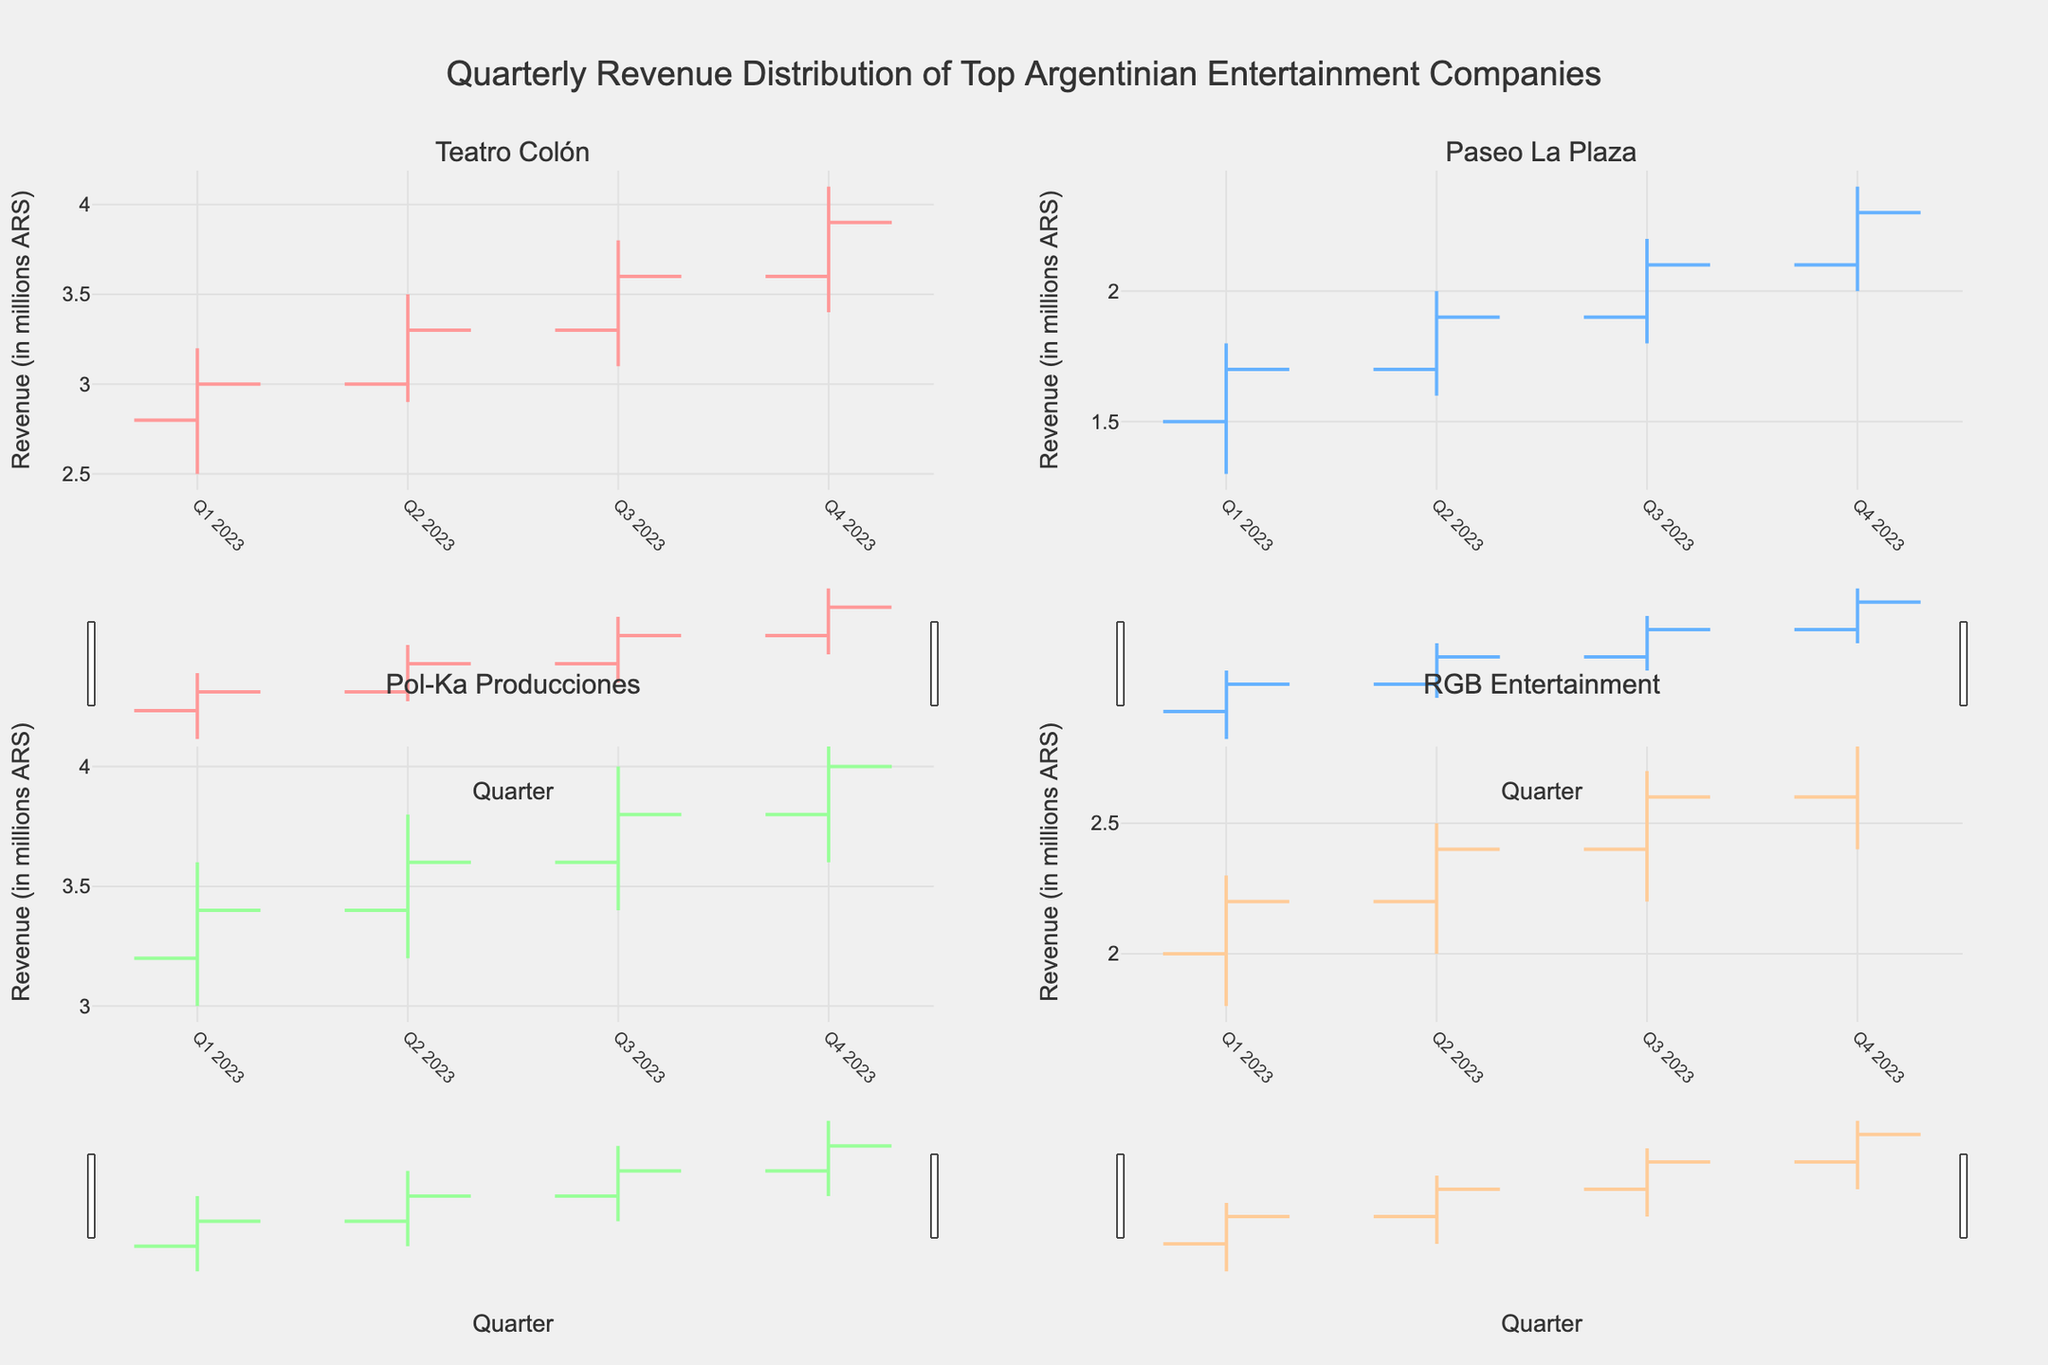What's the main title of the figure? The title is displayed prominently at the top of the figure, providing an overview of what's being shown. It can be read directly from the figure.
Answer: Quarterly Revenue Distribution of Top Argentinian Entertainment Companies Which company had the highest revenue in Q4 2023? To find the company with the highest revenue in Q4 2023, look at the High values in the Q4 2023 entries for all companies. Compare them to find the maximum value.
Answer: Pol-Ka Producciones What's the revenue range for Teatro Colón in Q2 2023? The revenue range is determined by the Low and High values. For Teatro Colón in Q2 2023, check the Low and High values in the second quarter.
Answer: 2.9 to 3.5 million ARS How did Paseo La Plaza's revenue change from Q1 2023 to Q4 2023? To determine the change, look at the Close values for Q1 2023 and Q4 2023 for Paseo La Plaza and subtract the Q1 value from the Q4 value.
Answer: Increase by 0.6 million ARS Which company showed the most consistent growth throughout 2023? Consistent growth means the Close values should incrementally increase each quarter. Compare the Close values for each quarter for all companies to see which one fits this pattern best.
Answer: Pol-Ka Producciones What's the average revenue of RGB Entertainment in 2023? Calculate the average by summing the Close values for all four quarters for RGB Entertainment and then divide by 4. Close values are 2.2, 2.4, 2.6, and 2.8. The sum is (2.2 + 2.4 + 2.6 + 2.8) = 10. The average is 10 / 4.
Answer: 2.5 million ARS Which quarter had the highest revenue for Teatro Colón? Check the High values for all quarters for Teatro Colón and determine which quarter has the highest High value.
Answer: Q4 2023 Was there any quarter when Paseo La Plaza's revenue decreased compared to the previous quarter? Compare the Close values of consecutive quarters for Paseo La Plaza and see if any quarter has a lower value than the previous one.
Answer: No What's the median closing revenue for Pol-Ka Producciones in 2023? To find the median, list the Close values for all quarters in ascending order and find the middle value. If there's an even number of values, average the two middle ones. The Close values are 3.4, 3.6, 3.8, 4.0, sorted as 3.4, 3.6, 3.8, 4.0. The median is the average of the two middle values, (3.6 + 3.8)/2.
Answer: 3.7 million ARS 